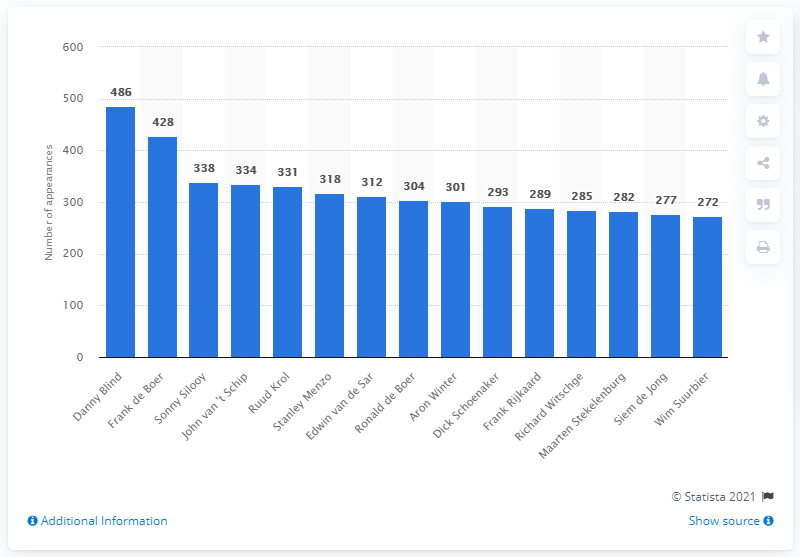Highlight a few significant elements in this photo. Danny Blind was the player with the most appearances in 2020. Danny Blind played 486 games for Ajax. 